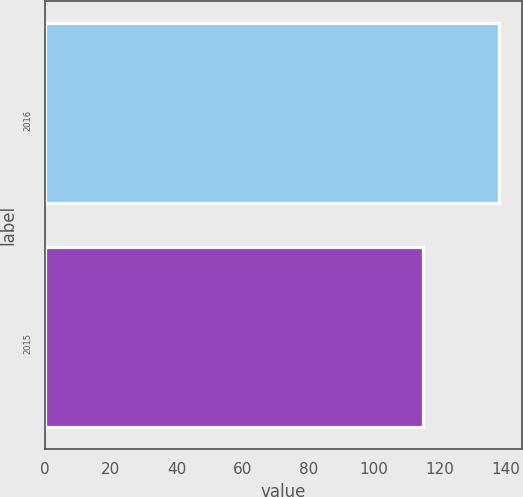Convert chart to OTSL. <chart><loc_0><loc_0><loc_500><loc_500><bar_chart><fcel>2016<fcel>2015<nl><fcel>138<fcel>115<nl></chart> 